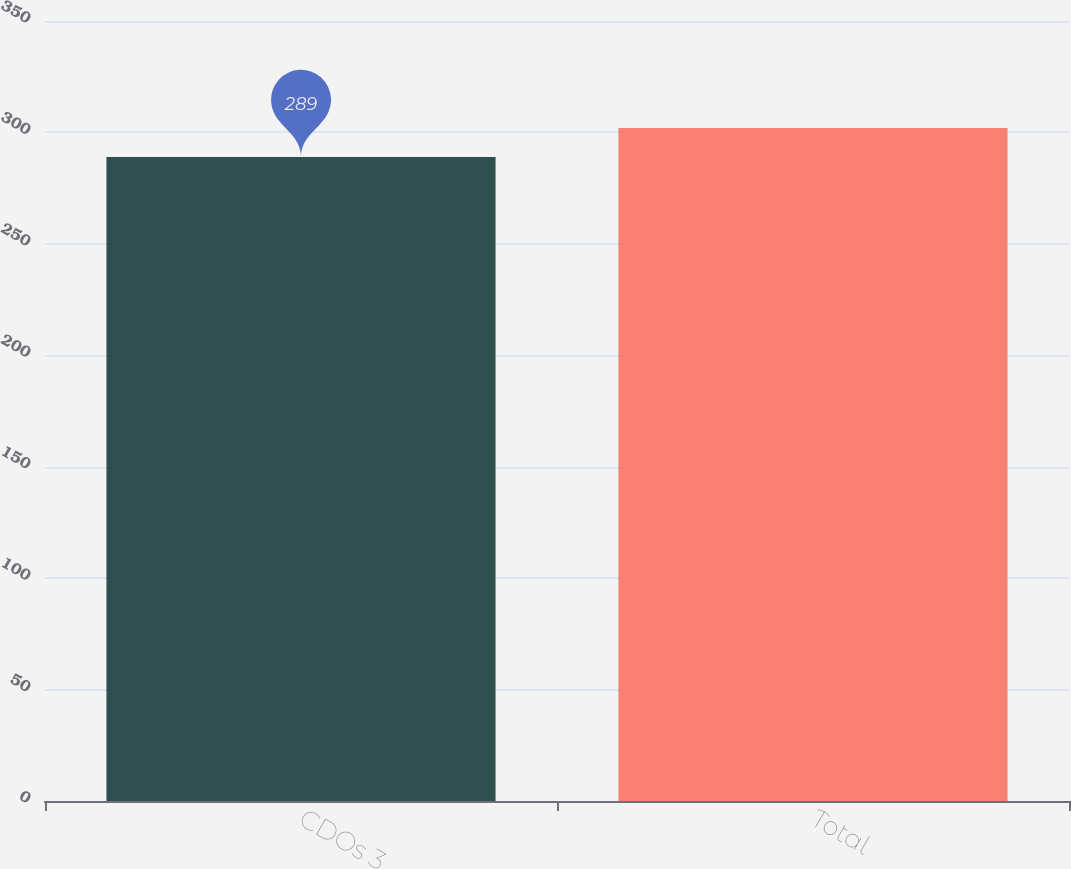<chart> <loc_0><loc_0><loc_500><loc_500><bar_chart><fcel>CDOs 3<fcel>Total<nl><fcel>289<fcel>302<nl></chart> 